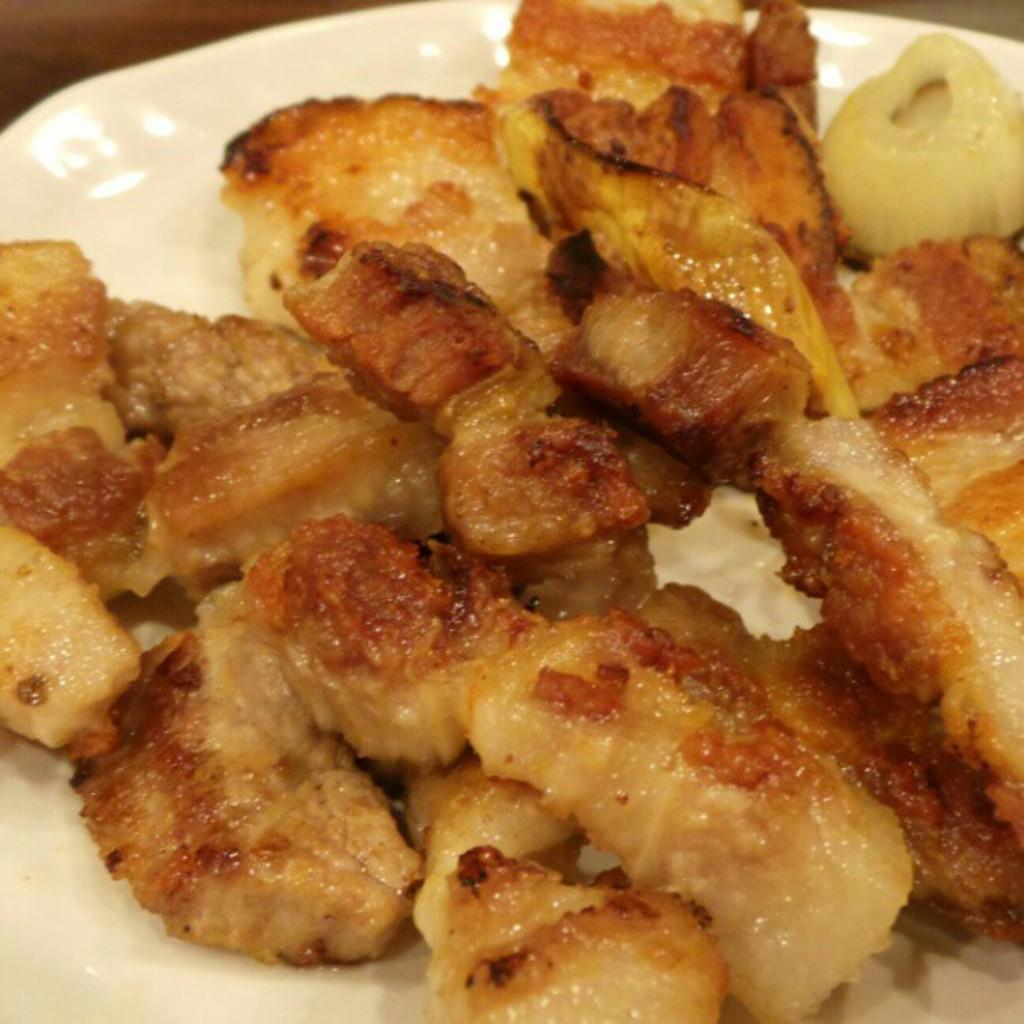What is the main subject of the image? There is a food item in the image. How is the food item presented? The food item is on a plate. Where is the plate located? The plate is on a platform. What letters does the sister write to the food item in the image? There is no sister or letters present in the image; it only features a food item on a plate on a platform. 